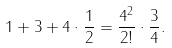<formula> <loc_0><loc_0><loc_500><loc_500>1 + 3 + 4 \cdot \frac { 1 } { 2 } = \frac { 4 ^ { 2 } } { 2 ! } \cdot \frac { 3 } { 4 } .</formula> 